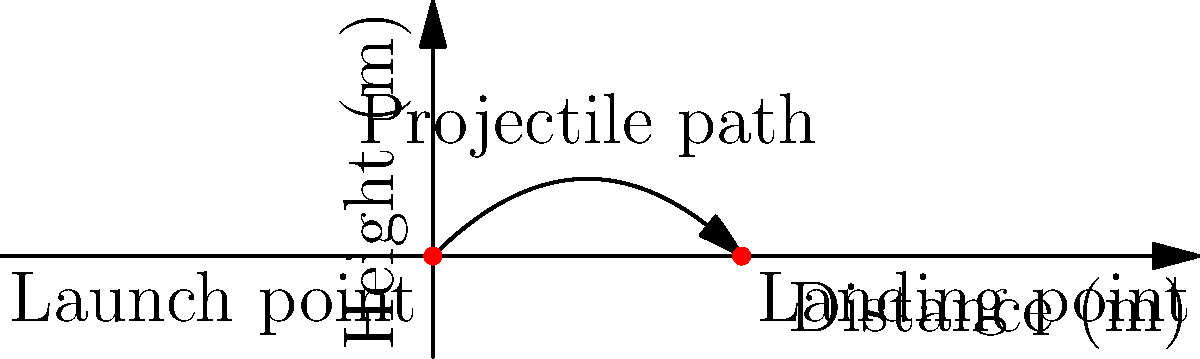A projectile is launched from ground level with an initial velocity of 20 m/s at an angle of 45° to the horizontal. Assuming air resistance is negligible, what is the maximum height reached by the projectile? (Use $g = 9.8$ m/s²) To find the maximum height, we can follow these steps:

1) The vertical component of the initial velocity is:
   $v_{0y} = v_0 \sin(\theta) = 20 \sin(45°) = 20 \cdot \frac{\sqrt{2}}{2} \approx 14.14$ m/s

2) The time to reach the maximum height is when the vertical velocity becomes zero:
   $v_y = v_{0y} - gt = 0$
   $t = \frac{v_{0y}}{g} = \frac{14.14}{9.8} \approx 1.44$ seconds

3) The maximum height can be calculated using the equation:
   $h = v_{0y}t - \frac{1}{2}gt^2$

4) Substituting the values:
   $h = 14.14 \cdot 1.44 - \frac{1}{2} \cdot 9.8 \cdot 1.44^2$
   $h = 20.36 - 10.18 = 10.18$ meters

Therefore, the maximum height reached by the projectile is approximately 10.18 meters.

This problem demonstrates the parabolic motion of projectiles, a fundamental concept in physics that's crucial for understanding many real-world applications, from sports to engineering.
Answer: 10.18 meters 